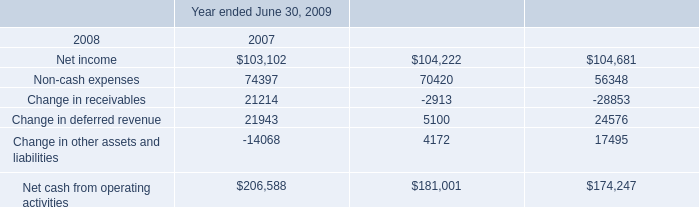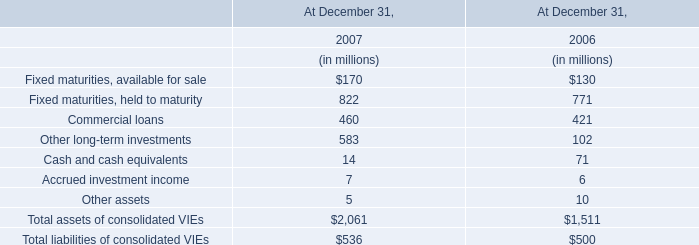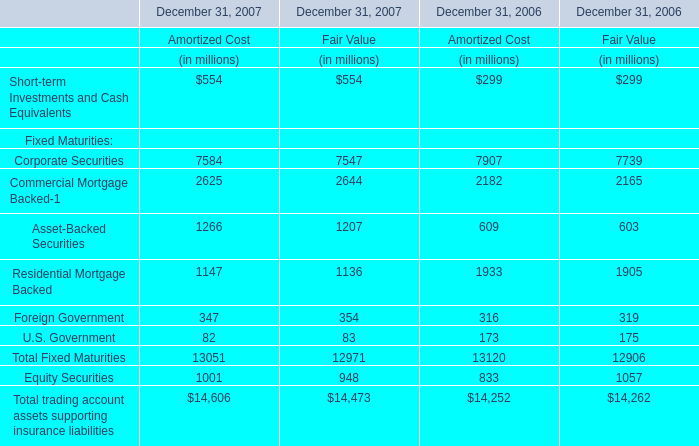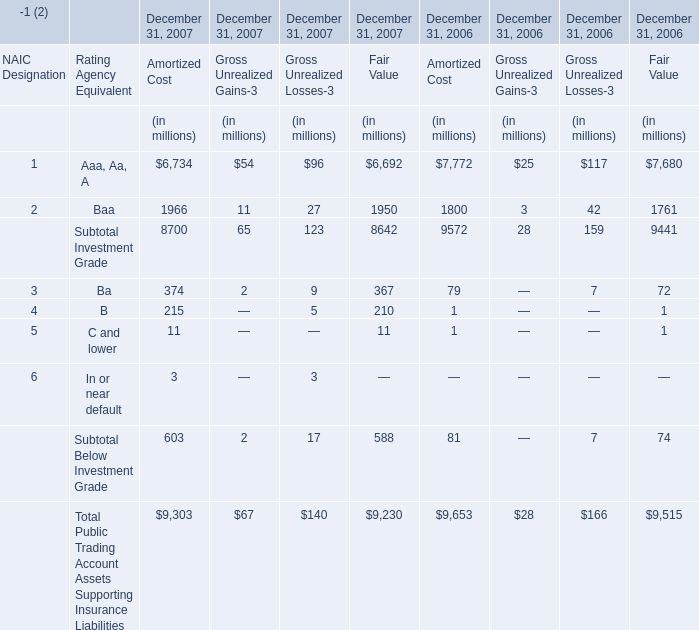what was the percentage change in the company 2019s cash and cash equivalents from june 302008 to 2009 
Computations: ((118251 - 65565) / 65565)
Answer: 0.80357. 